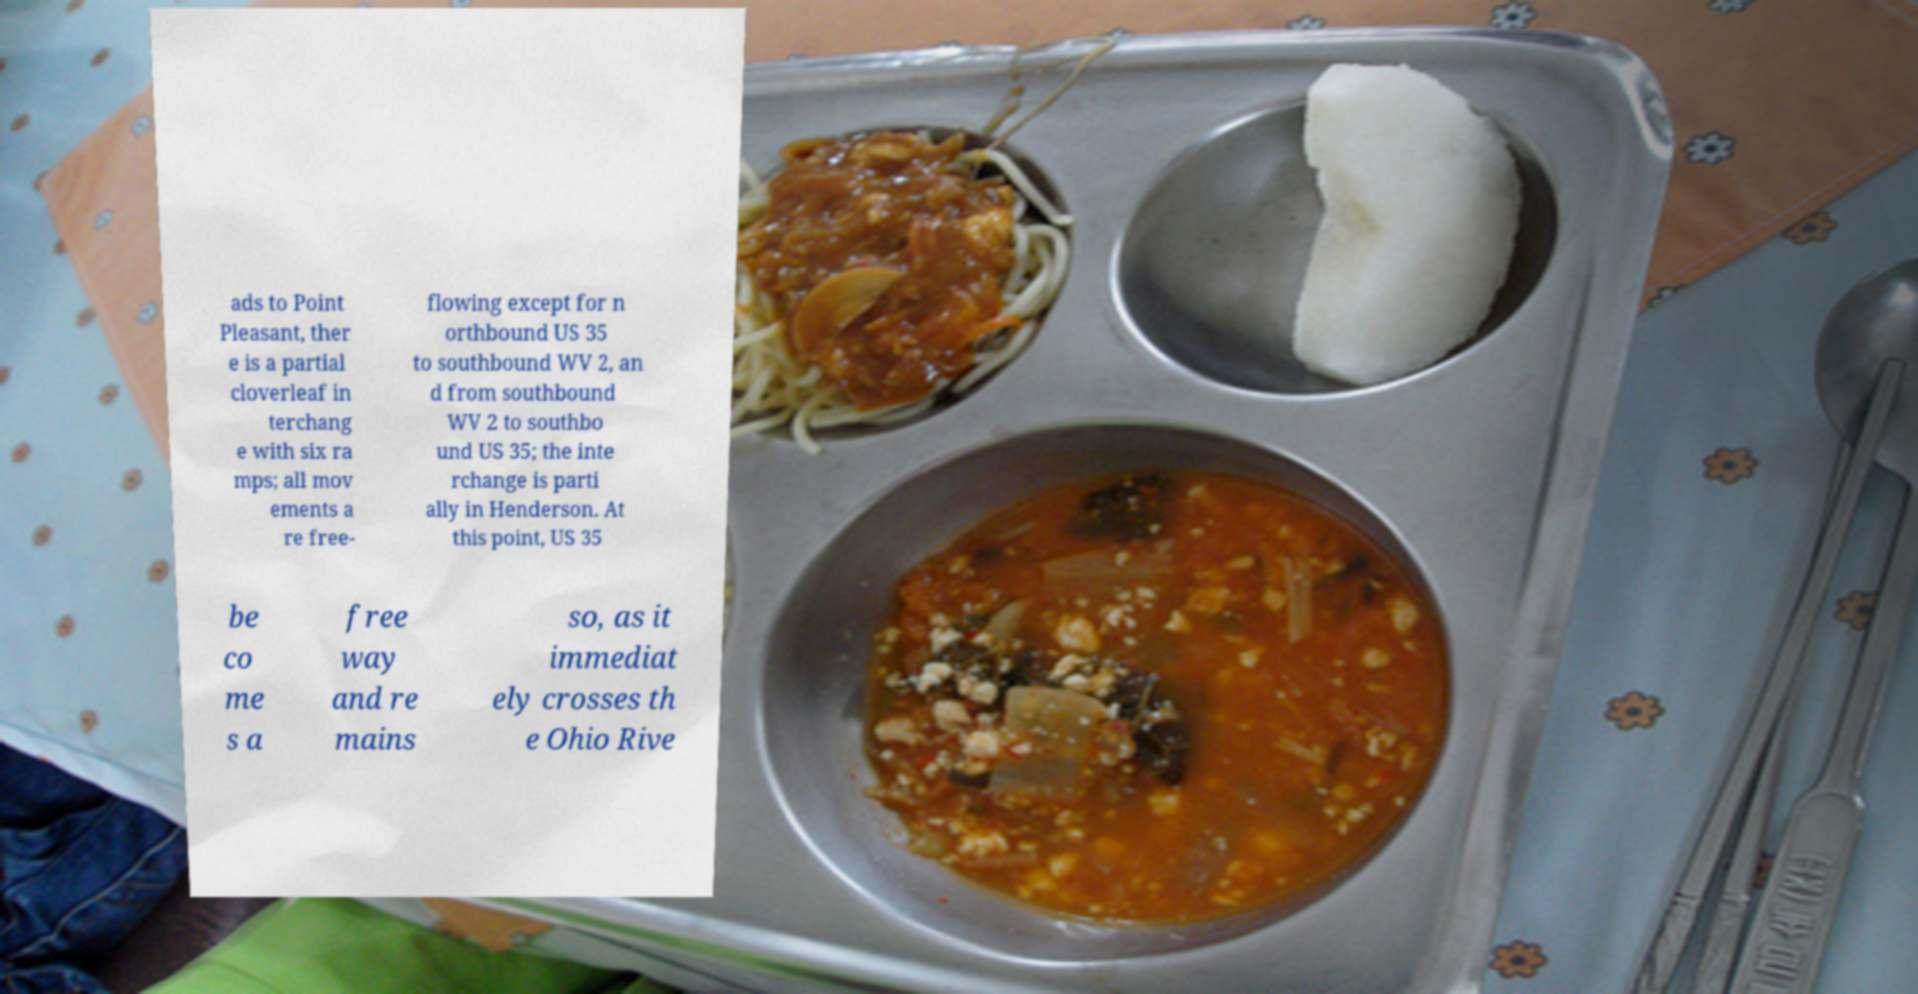Could you assist in decoding the text presented in this image and type it out clearly? ads to Point Pleasant, ther e is a partial cloverleaf in terchang e with six ra mps; all mov ements a re free- flowing except for n orthbound US 35 to southbound WV 2, an d from southbound WV 2 to southbo und US 35; the inte rchange is parti ally in Henderson. At this point, US 35 be co me s a free way and re mains so, as it immediat ely crosses th e Ohio Rive 